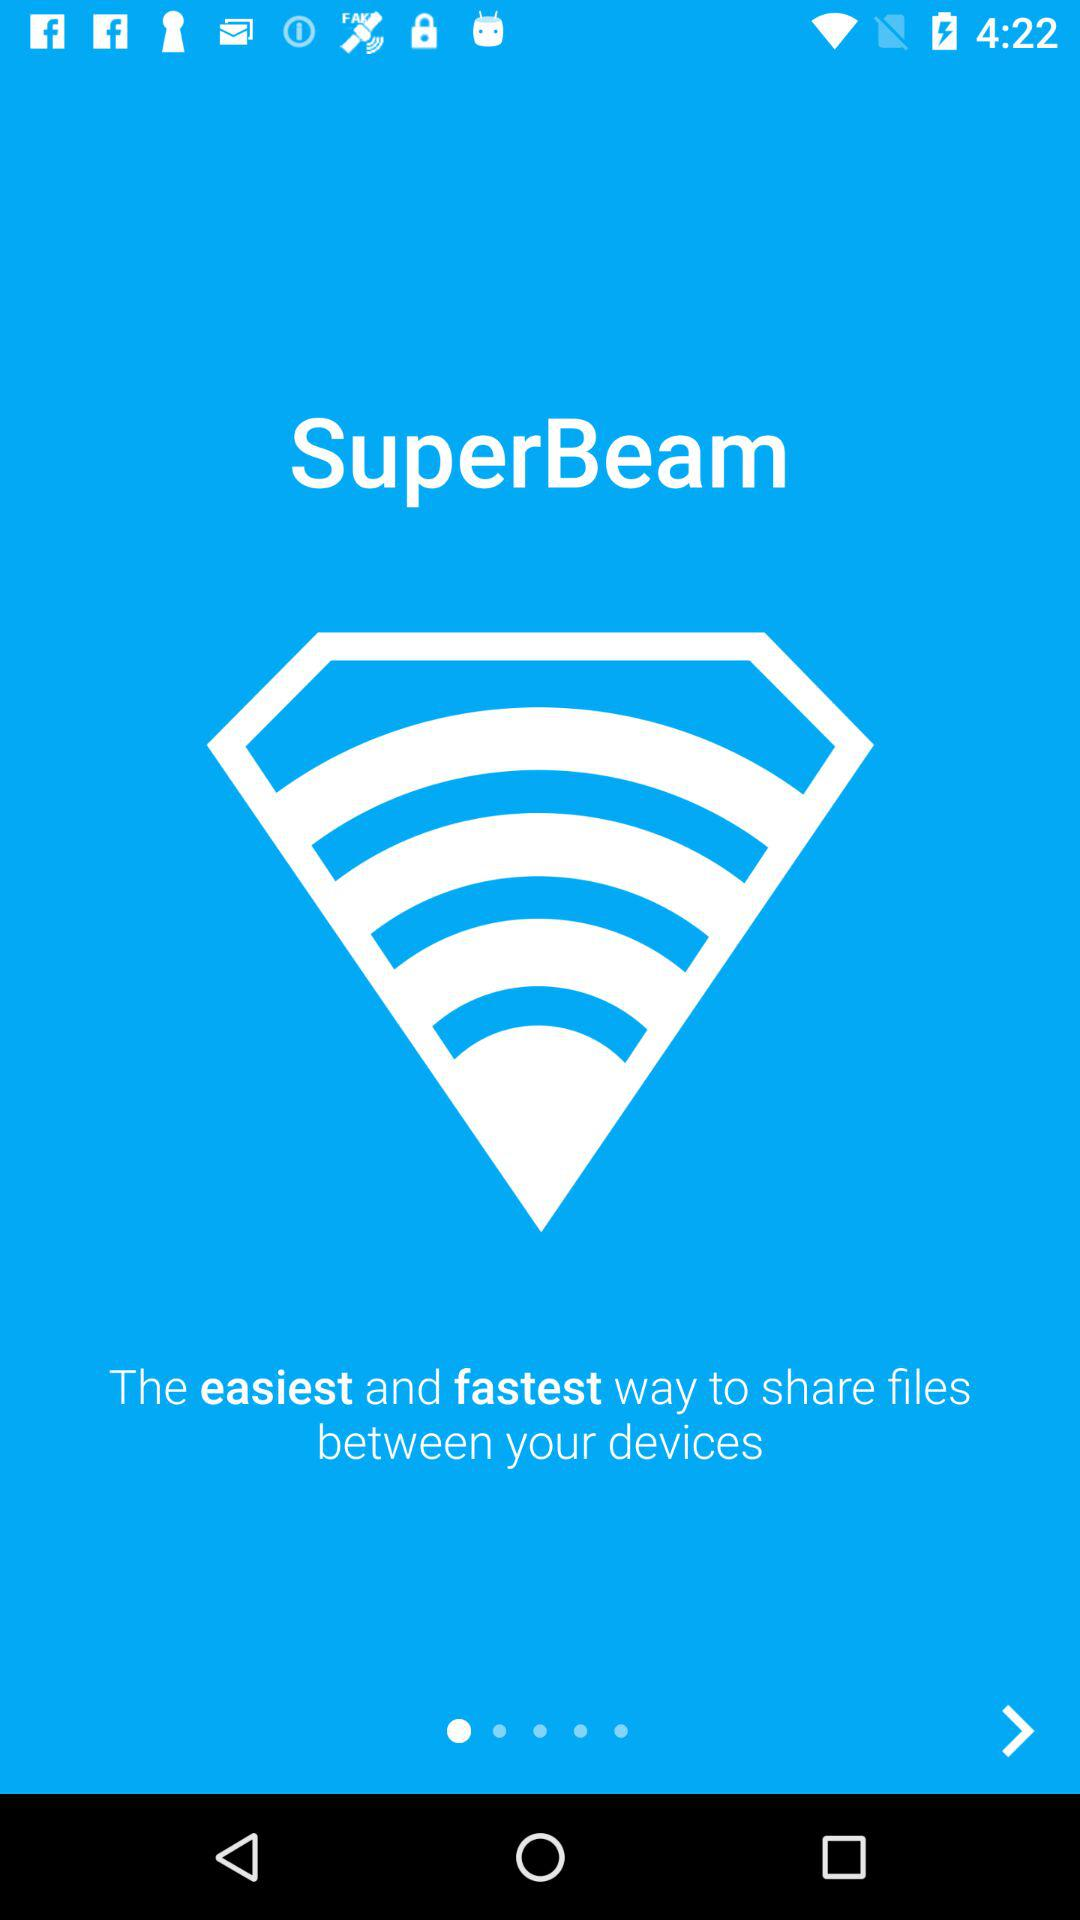What is the application name? The application name is "SuperBeam". 